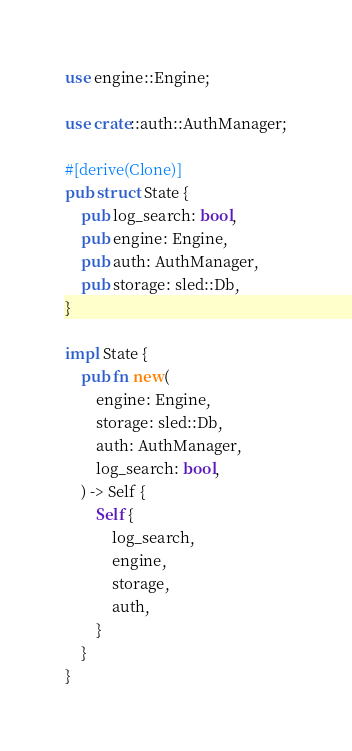<code> <loc_0><loc_0><loc_500><loc_500><_Rust_>use engine::Engine;

use crate::auth::AuthManager;

#[derive(Clone)]
pub struct State {
    pub log_search: bool,
    pub engine: Engine,
    pub auth: AuthManager,
    pub storage: sled::Db,
}

impl State {
    pub fn new(
        engine: Engine,
        storage: sled::Db,
        auth: AuthManager,
        log_search: bool,
    ) -> Self {
        Self {
            log_search,
            engine,
            storage,
            auth,
        }
    }
}
</code> 